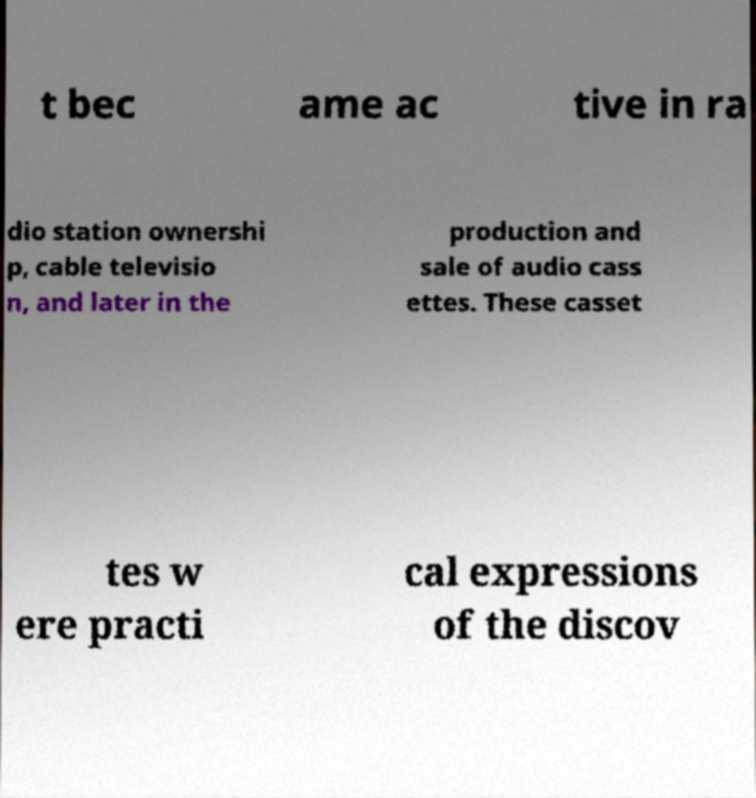Please identify and transcribe the text found in this image. t bec ame ac tive in ra dio station ownershi p, cable televisio n, and later in the production and sale of audio cass ettes. These casset tes w ere practi cal expressions of the discov 